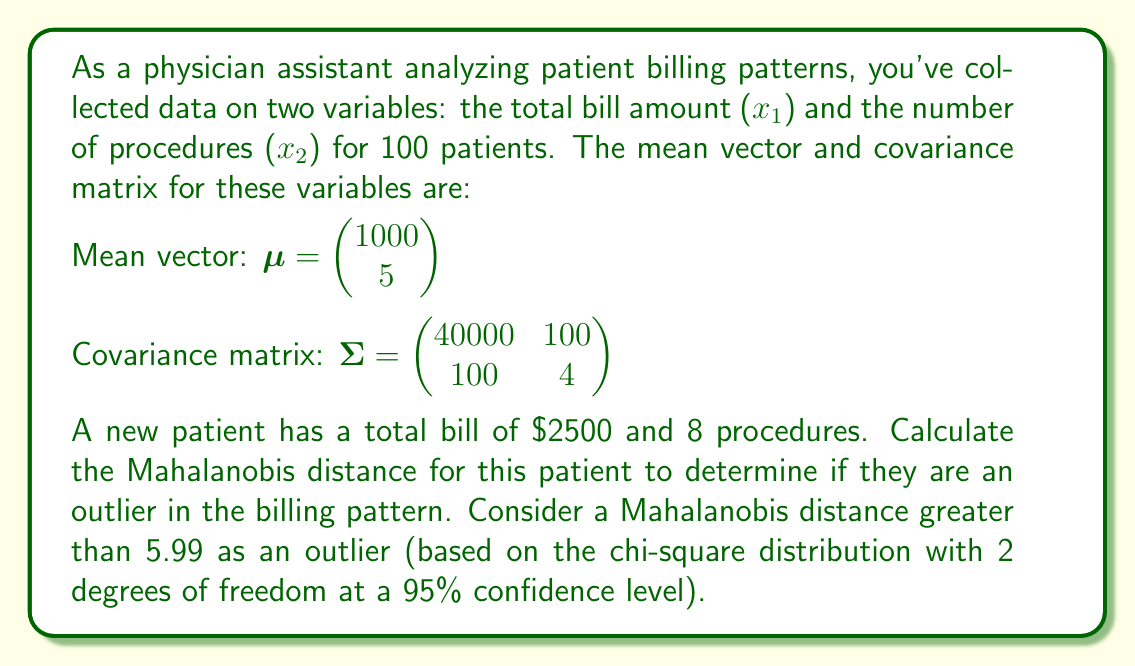Give your solution to this math problem. To solve this problem, we'll follow these steps:

1) First, recall the formula for the Mahalanobis distance:

   $$D^2 = (\mathbf{x} - \boldsymbol{\mu})^T \boldsymbol{\Sigma}^{-1} (\mathbf{x} - \boldsymbol{\mu})$$

   where $\mathbf{x}$ is the vector of observations, $\boldsymbol{\mu}$ is the mean vector, and $\boldsymbol{\Sigma}$ is the covariance matrix.

2) We need to calculate $\boldsymbol{\Sigma}^{-1}$. For a 2x2 matrix, the inverse is:

   $$\boldsymbol{\Sigma}^{-1} = \frac{1}{ad-bc}\begin{pmatrix} d & -b \\ -c & a \end{pmatrix}$$

   where $a=40000$, $b=100$, $c=100$, and $d=4$.

3) Calculate the determinant: $ad-bc = (40000)(4) - (100)(100) = 150000$

4) Therefore:

   $$\boldsymbol{\Sigma}^{-1} = \frac{1}{150000}\begin{pmatrix} 4 & -100 \\ -100 & 40000 \end{pmatrix}$$

5) Now, let's calculate $(\mathbf{x} - \boldsymbol{\mu})$:

   $$\mathbf{x} - \boldsymbol{\mu} = \begin{pmatrix} 2500 \\ 8 \end{pmatrix} - \begin{pmatrix} 1000 \\ 5 \end{pmatrix} = \begin{pmatrix} 1500 \\ 3 \end{pmatrix}$$

6) Next, we calculate $(\mathbf{x} - \boldsymbol{\mu})^T \boldsymbol{\Sigma}^{-1} (\mathbf{x} - \boldsymbol{\mu})$:

   $$\begin{pmatrix} 1500 & 3 \end{pmatrix} \frac{1}{150000}\begin{pmatrix} 4 & -100 \\ -100 & 40000 \end{pmatrix} \begin{pmatrix} 1500 \\ 3 \end{pmatrix}$$

7) Multiplying these matrices:

   $$\frac{1}{150000}(1500(4) + 3(-100))(1500) + (1500(-100) + 3(40000))(3)$$

   $$= \frac{1}{150000}(5700)(1500) + (-150000 + 120000)(3)$$

   $$= \frac{8550000 + (-30000)(3)}{150000} = 57 - 0.6 = 56.4$$

8) The Mahalanobis distance is the square root of this value:

   $$D = \sqrt{56.4} \approx 7.51$$

9) Since 7.51 > 5.99, this patient is considered an outlier in the billing pattern.
Answer: The Mahalanobis distance for the new patient is approximately 7.51, which is greater than the threshold of 5.99. Therefore, this patient is considered an outlier in the billing pattern. 